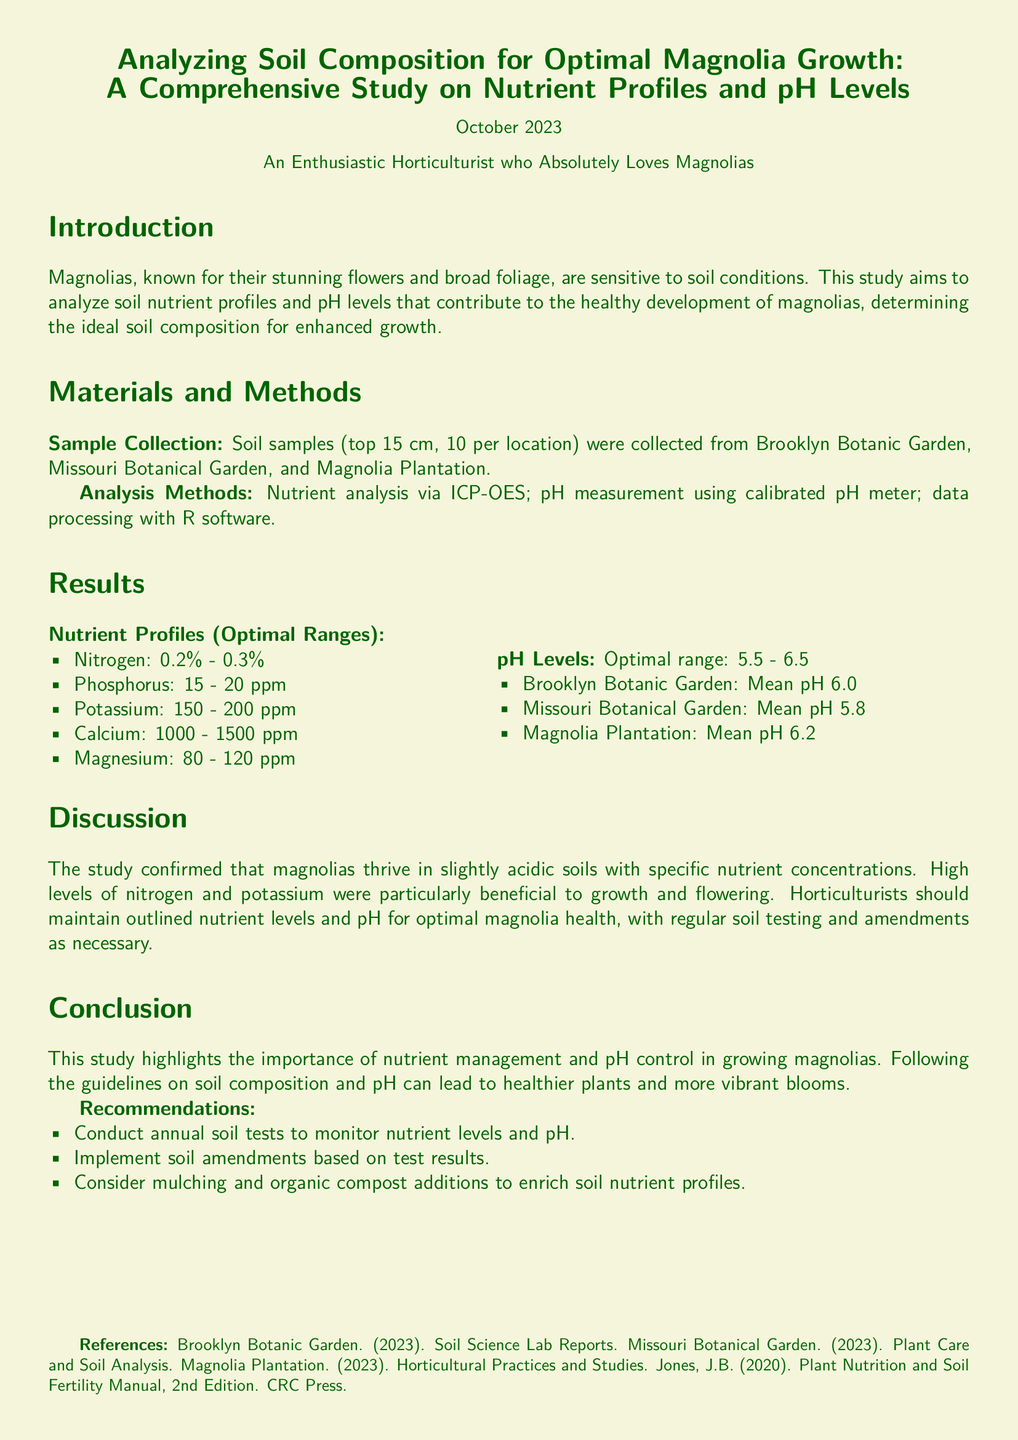what is the title of the study? The title of the study is stated at the beginning of the document, which is "Analyzing Soil Composition for Optimal Magnolia Growth: A Comprehensive Study on Nutrient Profiles and pH Levels."
Answer: Analyzing Soil Composition for Optimal Magnolia Growth: A Comprehensive Study on Nutrient Profiles and pH Levels how many soil samples were collected? The document mentions that soil samples were collected from various locations, with a specific count of 10 per location, although the total number is not explicitly listed.
Answer: 10 per location what is the optimal pH range for magnolias? The optimal pH range for magnolias is provided in the results section, clearly stated as 5.5 - 6.5.
Answer: 5.5 - 6.5 which location had the highest mean pH? The section on pH levels provides the mean pH for each location, indicating which one had the highest value. According to the data, the highest mean pH is from Magnolia Plantation.
Answer: Magnolia Plantation what nutrient concentration is recommended for potassium? The results section specifies an optimal range for potassium concentration, which can be directly retrieved from the nutrient profiles.
Answer: 150 - 200 ppm why is nitrogen important for magnolia growth? The discussion mentions high levels of nitrogen as being particularly beneficial for growth and flowering, indicating its significance.
Answer: Particularly beneficial to growth and flowering what should horticulturists do for optimal magnolia health? The conclusion suggests specific practices that horticulturists should follow in order to enhance the health of magnolias, focusing on soil composition and pH.
Answer: Regular soil testing and amendments what is a recommended practice for enriching soil? The recommendations section advises a particular practice for improving soil nutrient profiles, which is commonly used in horticulture.
Answer: Mulching and organic compost additions 